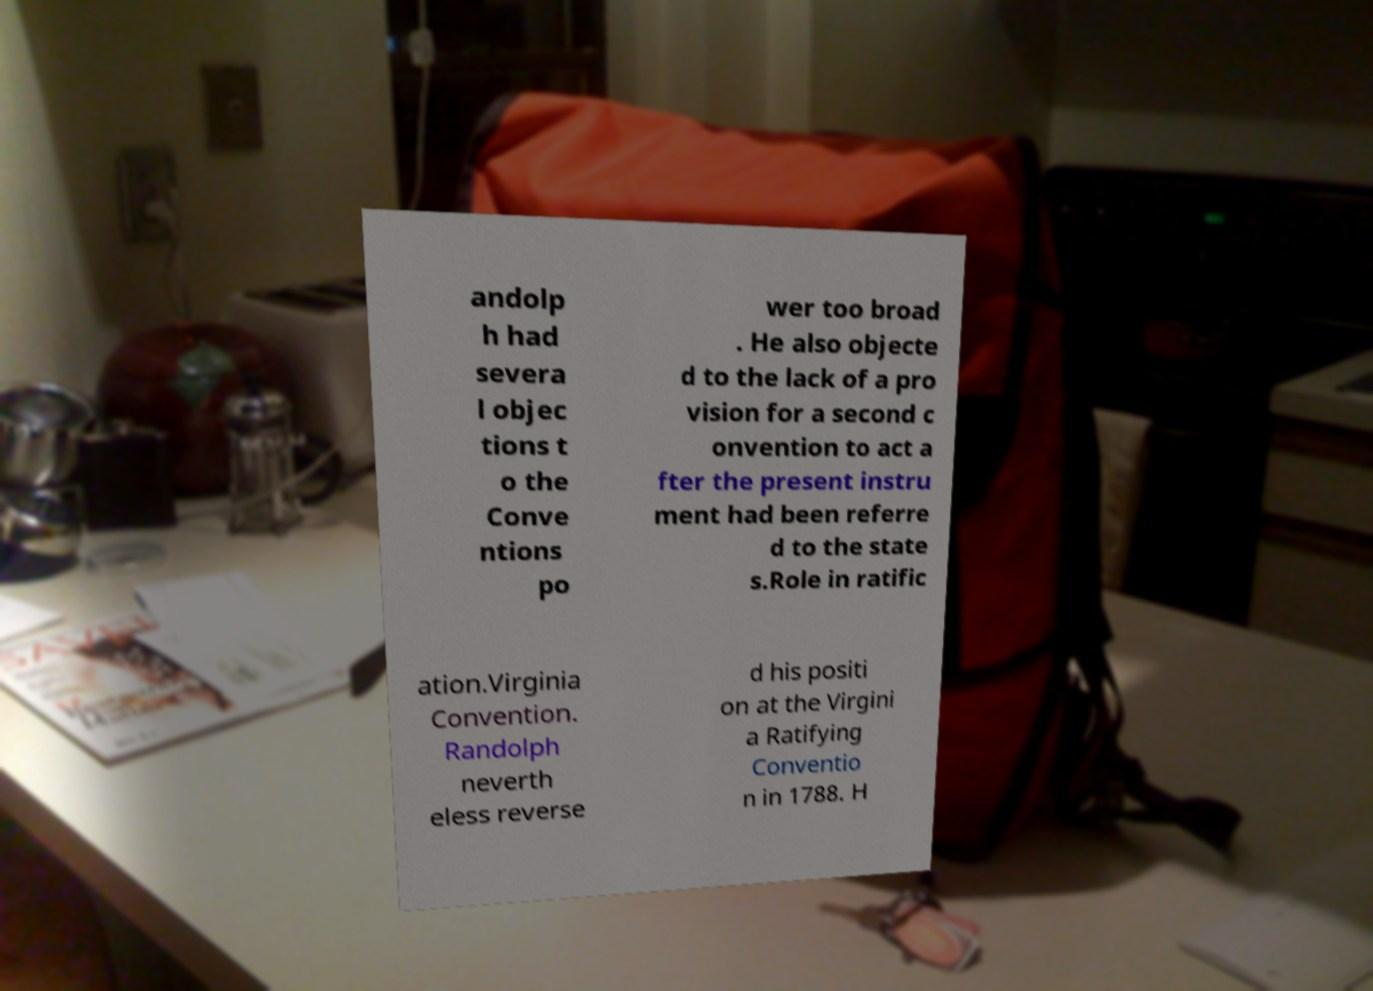Can you accurately transcribe the text from the provided image for me? andolp h had severa l objec tions t o the Conve ntions po wer too broad . He also objecte d to the lack of a pro vision for a second c onvention to act a fter the present instru ment had been referre d to the state s.Role in ratific ation.Virginia Convention. Randolph neverth eless reverse d his positi on at the Virgini a Ratifying Conventio n in 1788. H 